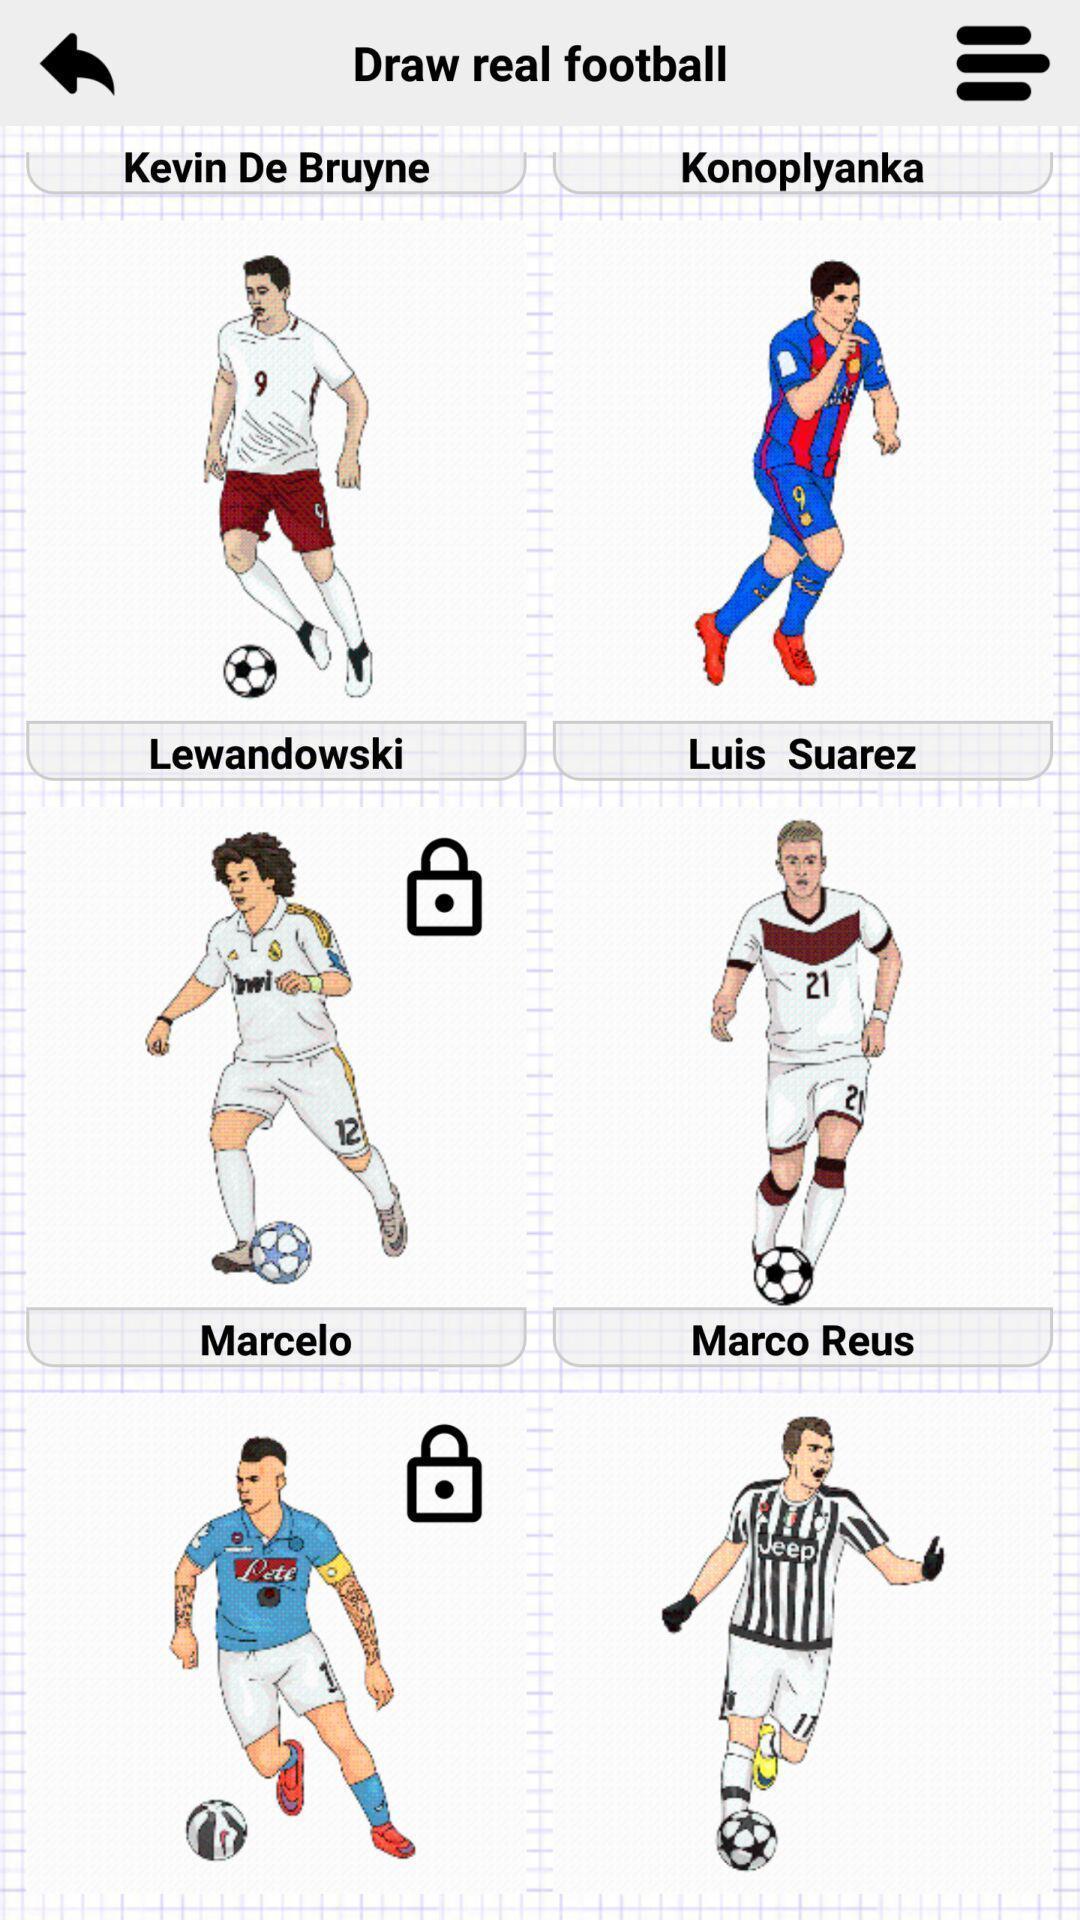Describe the content in this image. Various players in the gaming application to select. 